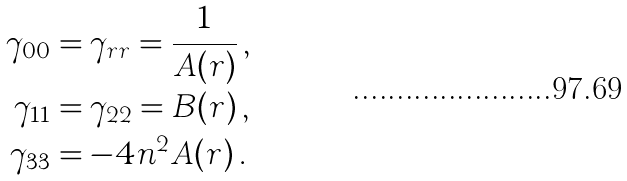<formula> <loc_0><loc_0><loc_500><loc_500>\gamma _ { 0 0 } & = \gamma _ { r r } = \frac { 1 } { A ( r ) } \, , \\ \gamma _ { 1 1 } & = \gamma _ { 2 2 } = B ( r ) \, , \\ \gamma _ { 3 3 } & = - 4 n ^ { 2 } A ( r ) \, .</formula> 